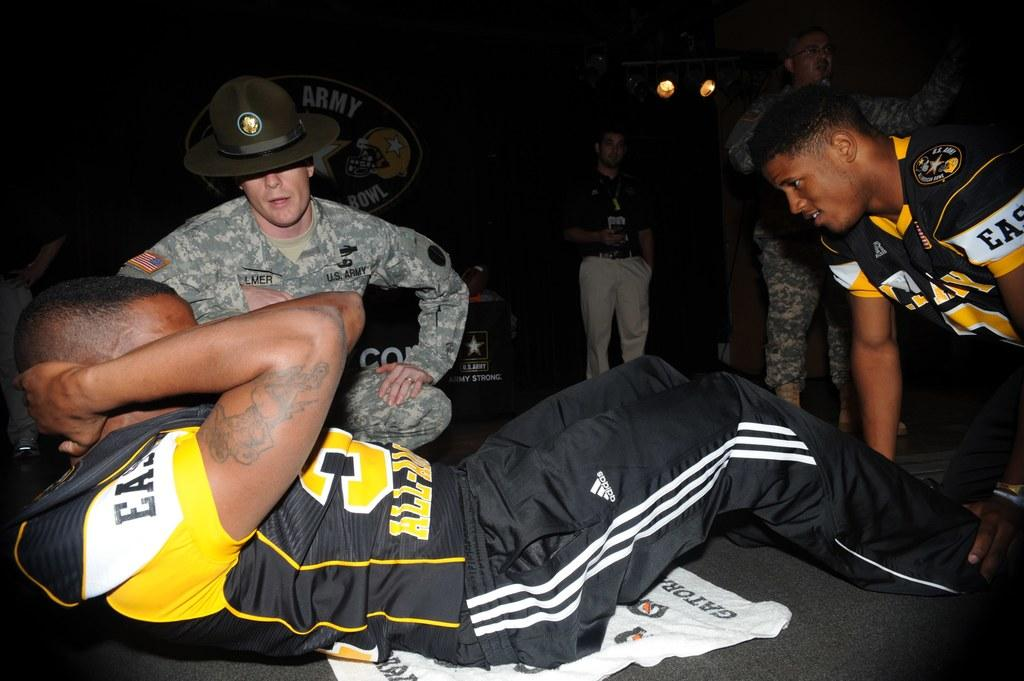<image>
Summarize the visual content of the image. Man doing situps while wearing a jersey taht says "EAST". 